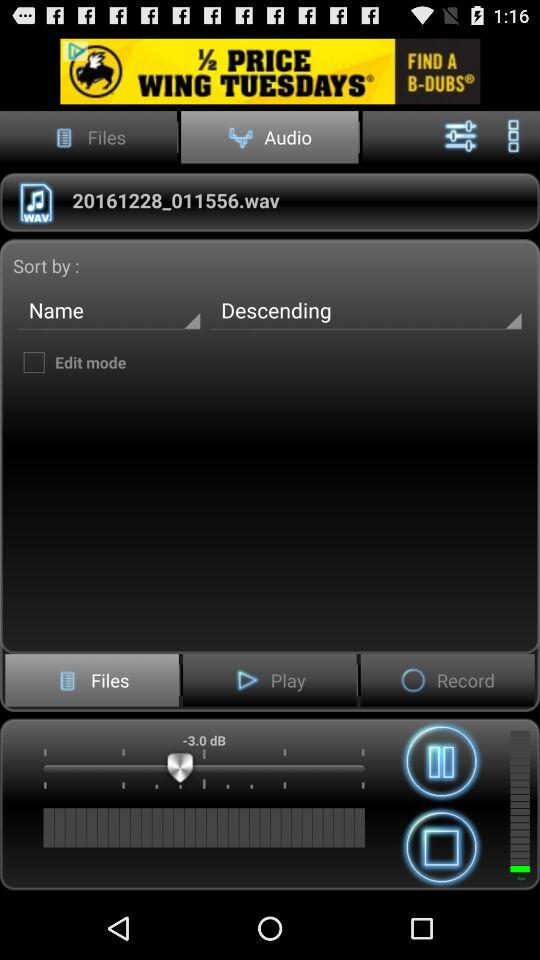Which audio is currently playing? The currently playing audio is "20161228_011556.wav". 